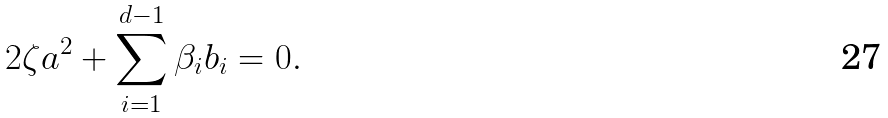Convert formula to latex. <formula><loc_0><loc_0><loc_500><loc_500>2 \zeta a ^ { 2 } + \sum _ { i = 1 } ^ { d - 1 } \beta _ { i } b _ { i } = 0 .</formula> 